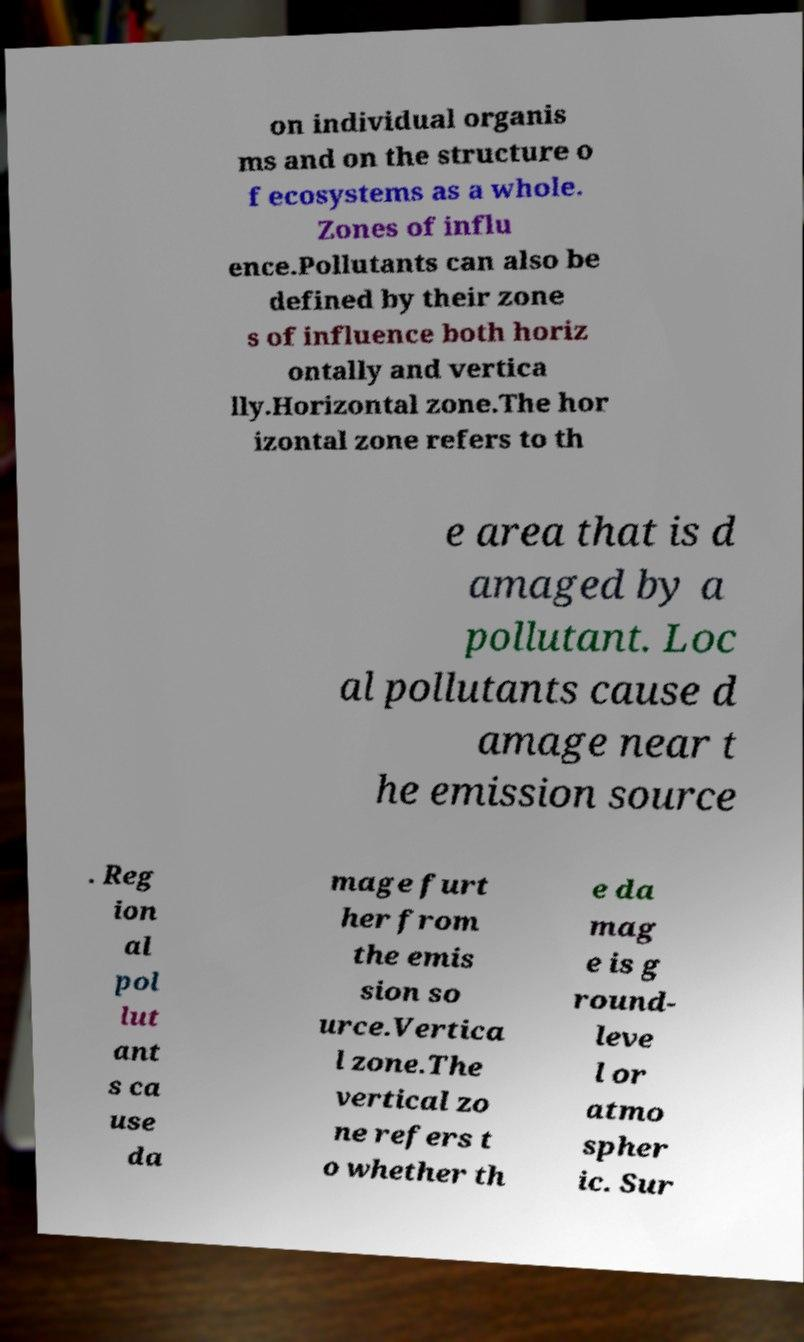For documentation purposes, I need the text within this image transcribed. Could you provide that? on individual organis ms and on the structure o f ecosystems as a whole. Zones of influ ence.Pollutants can also be defined by their zone s of influence both horiz ontally and vertica lly.Horizontal zone.The hor izontal zone refers to th e area that is d amaged by a pollutant. Loc al pollutants cause d amage near t he emission source . Reg ion al pol lut ant s ca use da mage furt her from the emis sion so urce.Vertica l zone.The vertical zo ne refers t o whether th e da mag e is g round- leve l or atmo spher ic. Sur 